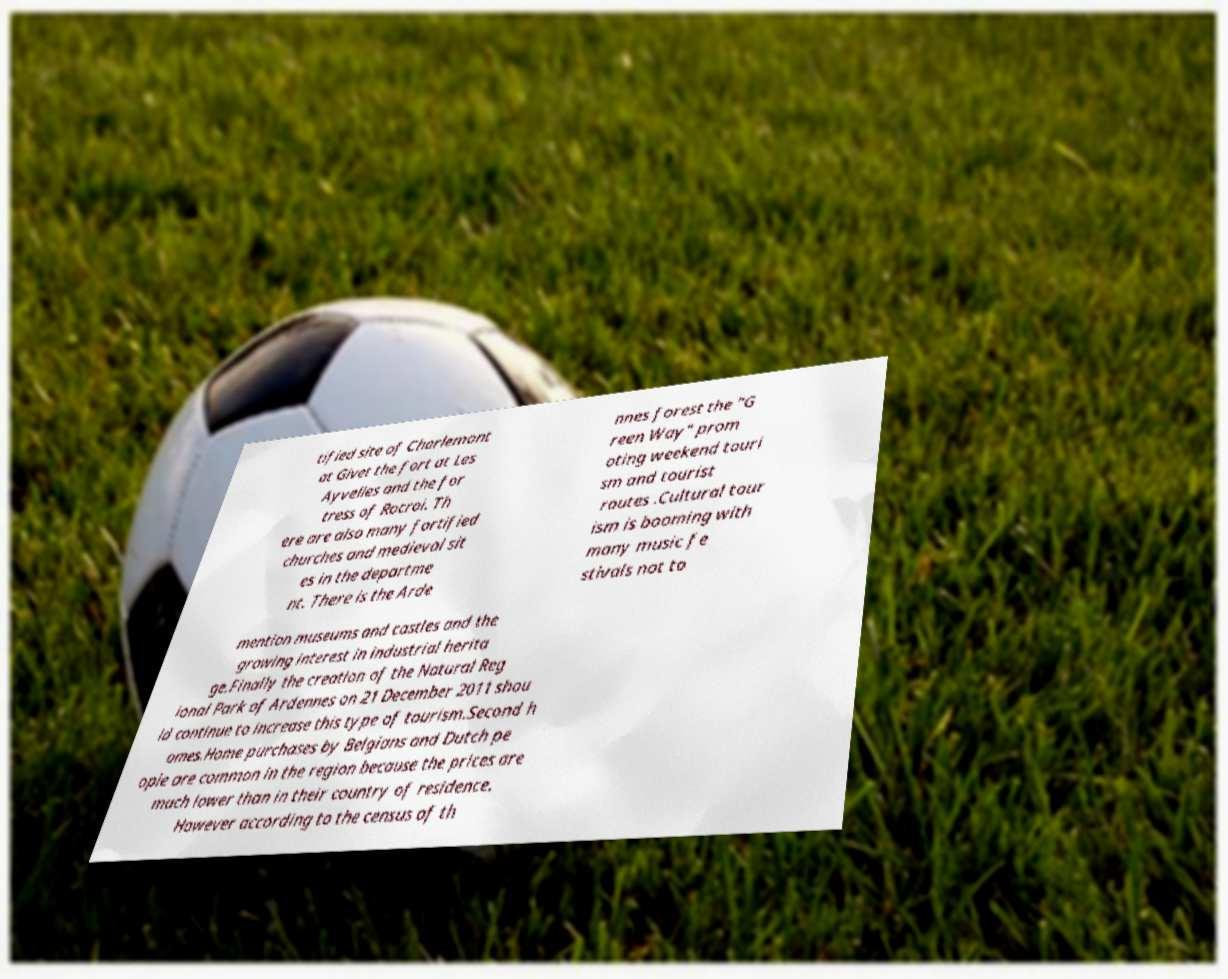What messages or text are displayed in this image? I need them in a readable, typed format. tified site of Charlemont at Givet the fort at Les Ayvelles and the for tress of Rocroi. Th ere are also many fortified churches and medieval sit es in the departme nt. There is the Arde nnes forest the "G reen Way" prom oting weekend touri sm and tourist routes .Cultural tour ism is booming with many music fe stivals not to mention museums and castles and the growing interest in industrial herita ge.Finally the creation of the Natural Reg ional Park of Ardennes on 21 December 2011 shou ld continue to increase this type of tourism.Second h omes.Home purchases by Belgians and Dutch pe ople are common in the region because the prices are much lower than in their country of residence. However according to the census of th 